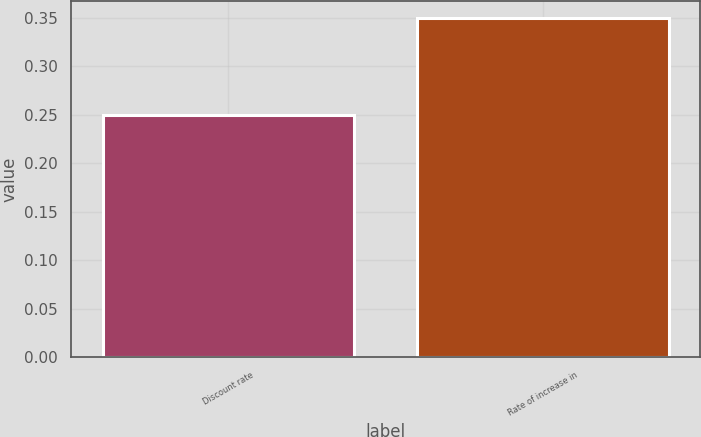Convert chart to OTSL. <chart><loc_0><loc_0><loc_500><loc_500><bar_chart><fcel>Discount rate<fcel>Rate of increase in<nl><fcel>0.25<fcel>0.35<nl></chart> 